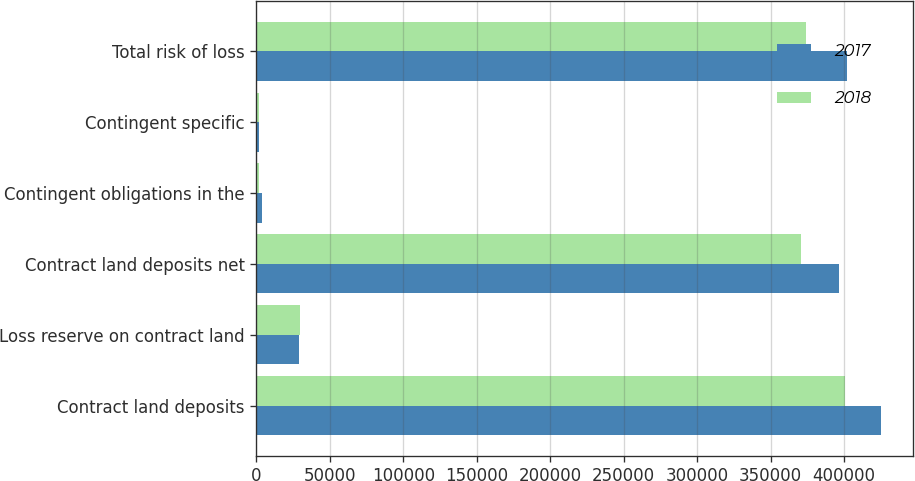Convert chart. <chart><loc_0><loc_0><loc_500><loc_500><stacked_bar_chart><ecel><fcel>Contract land deposits<fcel>Loss reserve on contract land<fcel>Contract land deposits net<fcel>Contingent obligations in the<fcel>Contingent specific<fcel>Total risk of loss<nl><fcel>2017<fcel>425393<fcel>29216<fcel>396177<fcel>3923<fcel>1505<fcel>401605<nl><fcel>2018<fcel>400428<fcel>29999<fcel>370429<fcel>1996<fcel>1505<fcel>373930<nl></chart> 